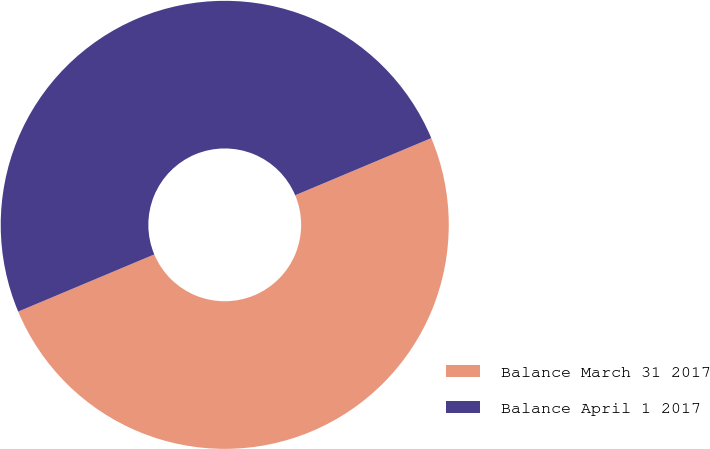<chart> <loc_0><loc_0><loc_500><loc_500><pie_chart><fcel>Balance March 31 2017<fcel>Balance April 1 2017<nl><fcel>50.0%<fcel>50.0%<nl></chart> 